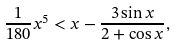Convert formula to latex. <formula><loc_0><loc_0><loc_500><loc_500>\frac { 1 } { 1 8 0 } x ^ { 5 } < x - \frac { 3 \sin x } { 2 + \cos x } ,</formula> 